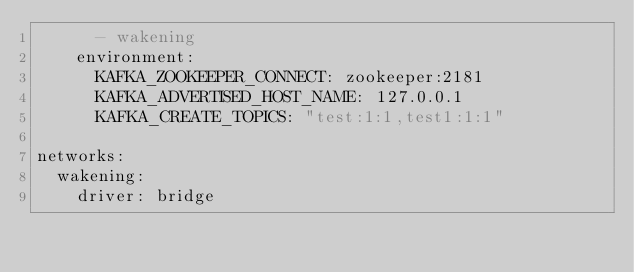<code> <loc_0><loc_0><loc_500><loc_500><_YAML_>      - wakening
    environment:
      KAFKA_ZOOKEEPER_CONNECT: zookeeper:2181
      KAFKA_ADVERTISED_HOST_NAME: 127.0.0.1
      KAFKA_CREATE_TOPICS: "test:1:1,test1:1:1"
      
networks:
  wakening:
    driver: bridge</code> 